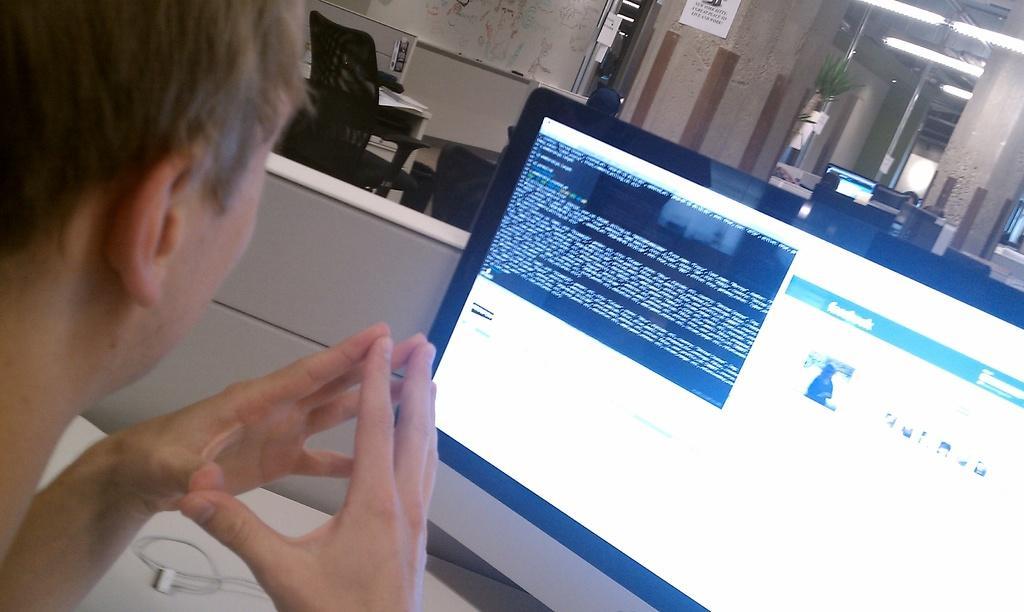In one or two sentences, can you explain what this image depicts? In the foreground of this picture, there is a man sitting near a computer. In the background, there are chairs, tables, wall, map, lights and the plants. 